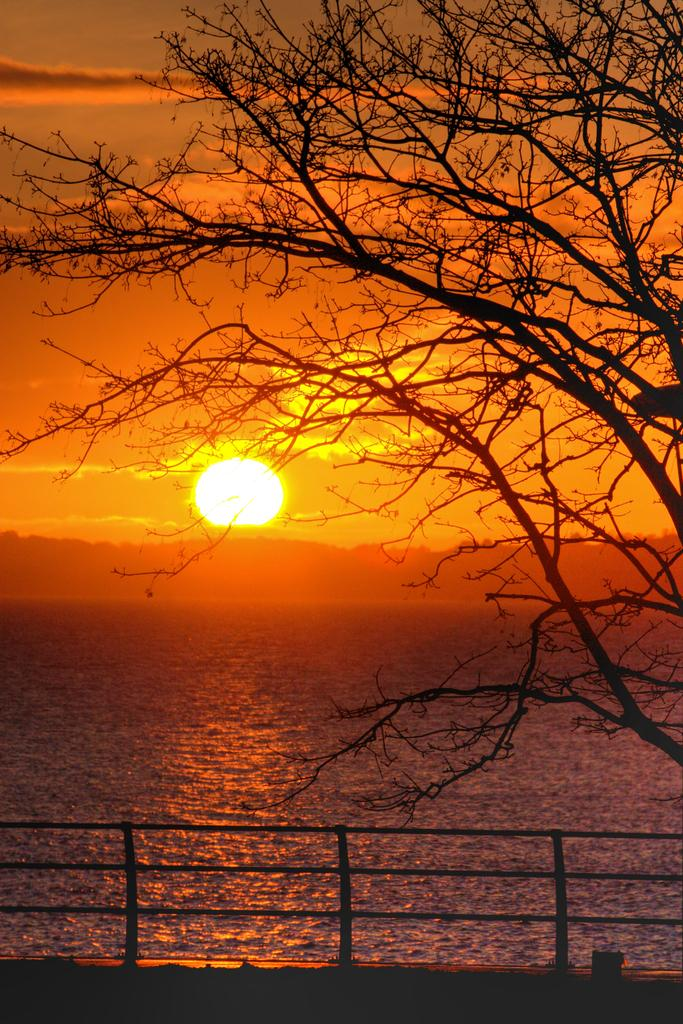What is happening to the sun in the image? The sun is rising in the sky in the image. What can be seen on the right side of the image? There is a tree on the right side of the image. What natural feature is present in the image? There is a river in the image. What is located at the bottom of the image? There is a safety barrier at the bottom of the image. What type of feast is being prepared near the river in the image? There is no indication of a feast or any food preparation in the image. 